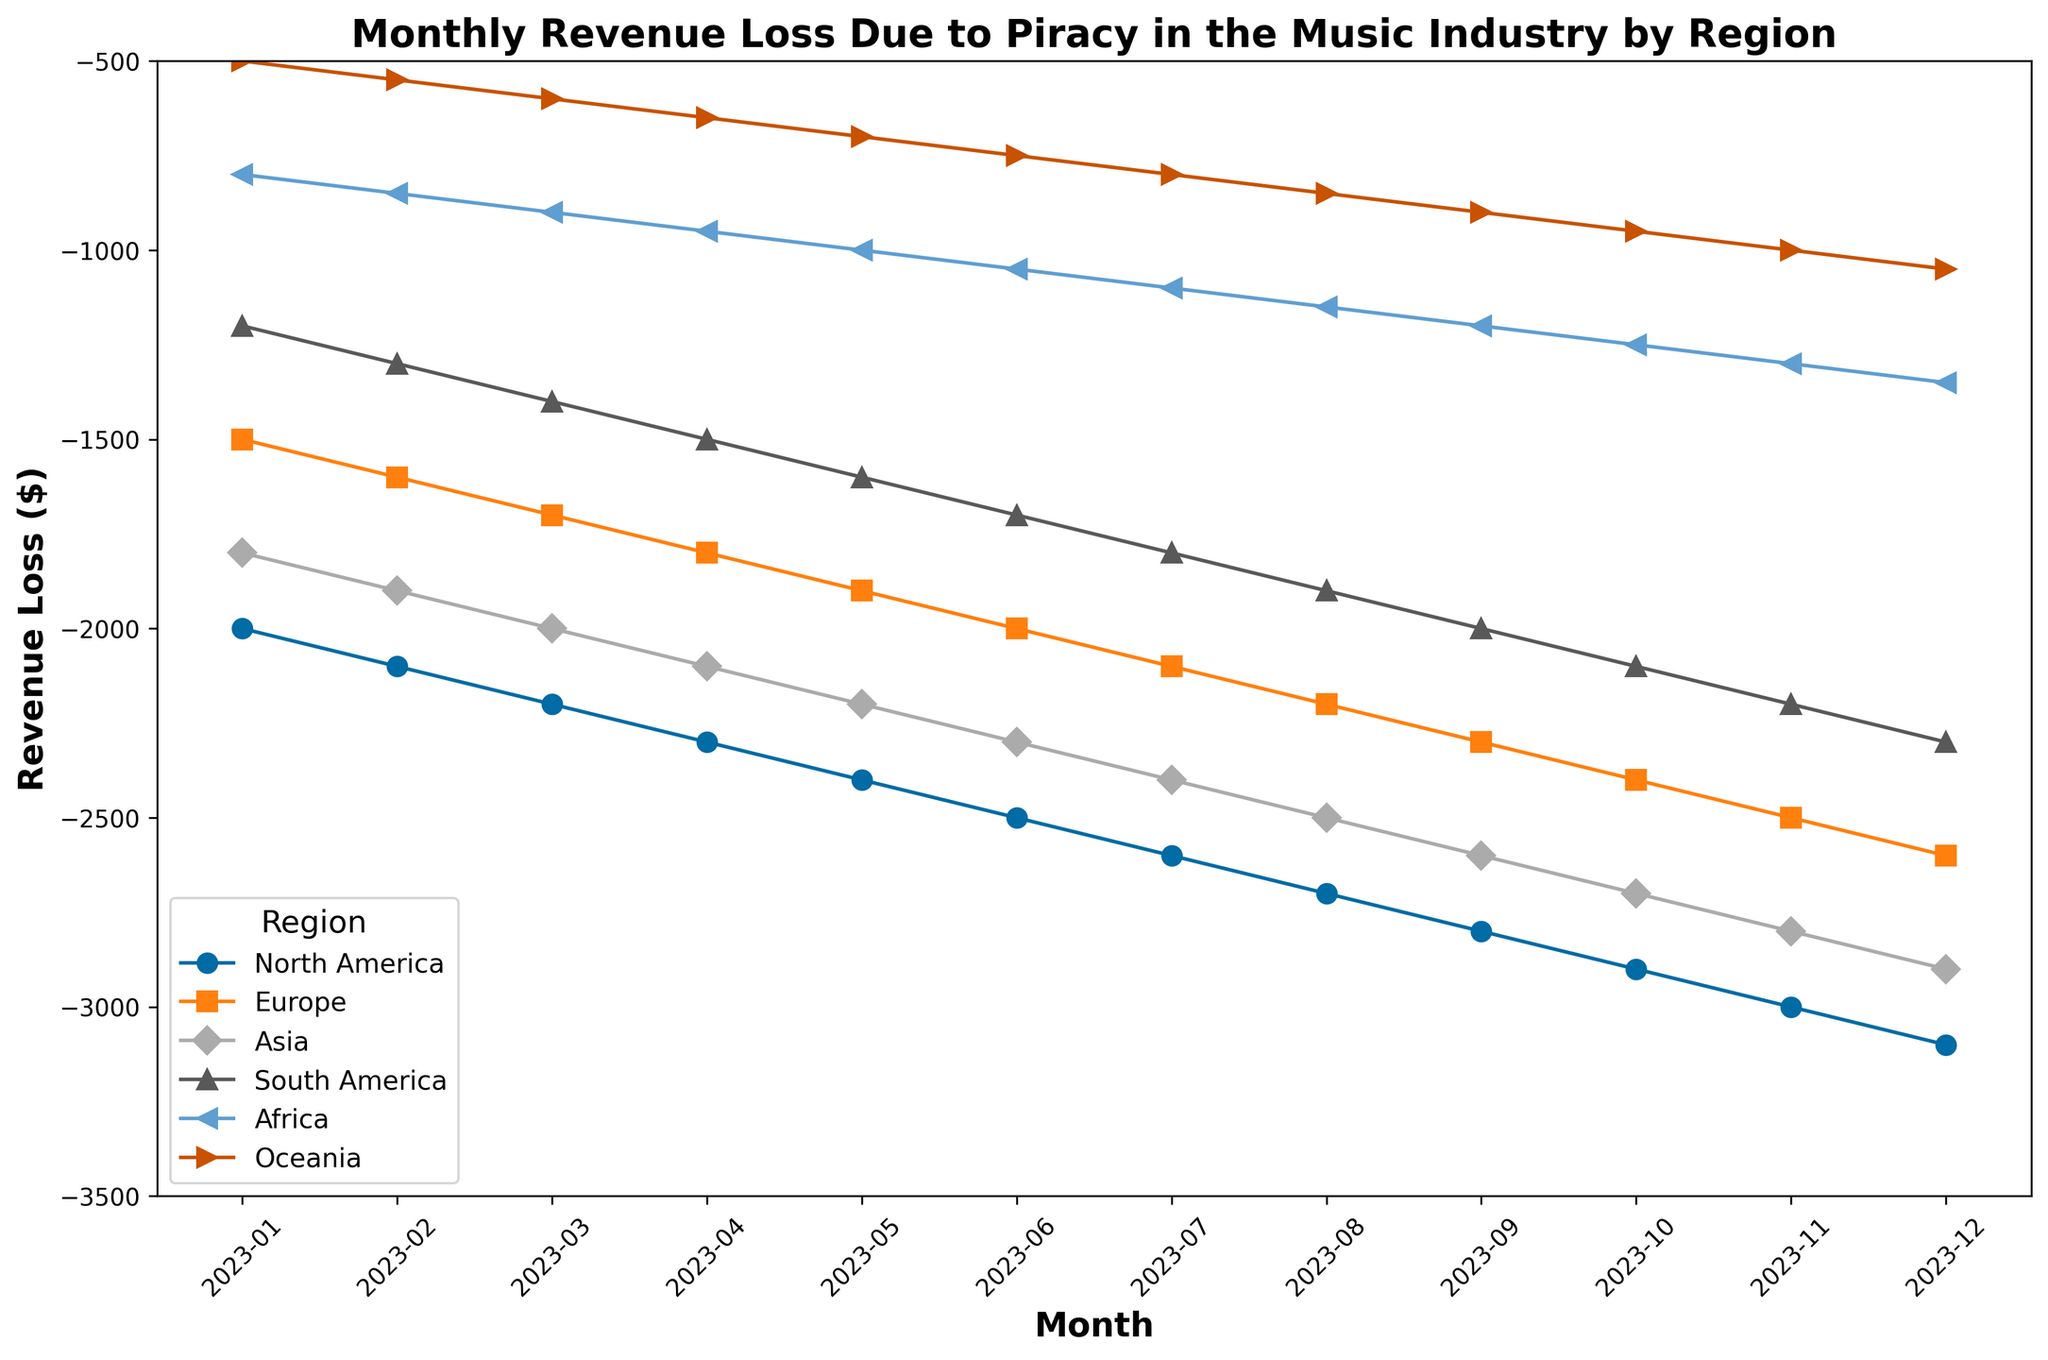Which region experienced the highest revenue loss consistently over the months? The highest revenue loss consistently over the months can be identified by looking at which region's line is at the lowest point in the chart across all months. North America consistently shows the highest revenue loss value each month.
Answer: North America By how much did the revenue loss in Asia increase from January to December? To find the increase for Asia, subtract the revenue loss in January from the revenue loss in December: -2900 (December) - (-1800) (January) = -2900 + 1800 = -1100
Answer: -1100 What is the average monthly revenue loss for Europe? To find the average, add the monthly revenue losses for Europe and divide by the number of months: (-1500 + -1600 + -1700 + -1800 + -1900 + -2000 + -2100 + -2200 + -2300 + -2400 + -2500 + -2600) / 12 = -21900 / 12 = -1825
Answer: -1825 Between which two consecutive months did South America see the largest increase in revenue loss? Calculate the increase in revenue loss for each consecutive month: February: -1300 - (-1200) = -100; March: -1400 - (-1300) = -100; April: -1500 - (-1400) = -100; May: -1600 - (-1500) = -100; June: -1700 - (-1600) = -100; July: -1800 - (-1700) = -100; August: -1900 - (-1800) = -100; September: -2000 - (-1900) = -100; October: -2100 - (-2000) = -100; November: -2200 - (-2100) = -100; December: -2300 - (-2200) = -100. Since the increase is the same for all months, any consecutive month is acceptable.
Answer: Any consecutive month Which region showed the least variability in revenue loss over the months? To determine which region shows the least variability, examine the lines that have the smallest spread and least steepness. Oceania has the smallest difference between the highest and lowest points, indicating less variability.
Answer: Oceania What is the combined revenue loss for all regions in April? Sum the revenue losses for all regions in April: -2300 (North America) + -1800 (Europe) + -2100 (Asia) + -1500 (South America) + -950 (Africa) + -650 (Oceania) = -9300
Answer: -9300 By how much did North America's revenue loss exceed Africa's revenue loss in December? Subtract Africa's revenue loss from North America's revenue loss for December: -3100 - (-1350) = -3100 + 1350 = -1750
Answer: -1750 